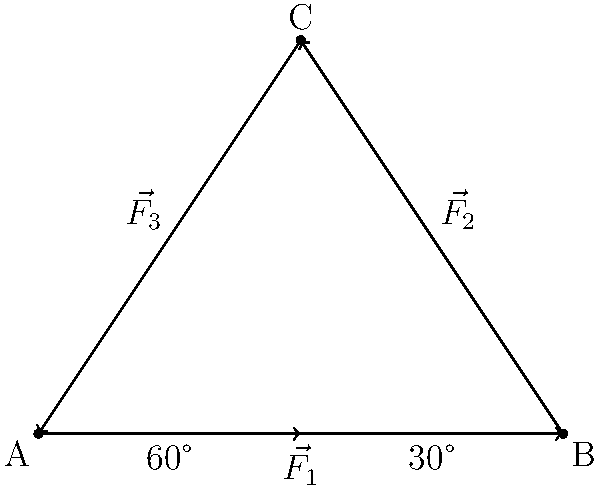The John G. Lawton's rigging system includes a triangular arrangement of forces as shown in the diagram. $\vec{F_1}$ has a magnitude of 1000 N and is horizontal. $\vec{F_2}$ makes an angle of 30° with the horizontal, and $\vec{F_3}$ makes an angle of 60° with the horizontal. If the system is in equilibrium, calculate the magnitude of $\vec{F_2}$. To solve this problem, we'll use the following steps:

1) For a system in equilibrium, the sum of forces in both x and y directions must be zero.

2) Let's define the positive x-direction as right and positive y-direction as up.

3) Break down the forces into their x and y components:
   $\vec{F_1}_x = 1000$ N, $\vec{F_1}_y = 0$ N
   $\vec{F_2}_x = F_2 \cos(30°)$, $\vec{F_2}_y = F_2 \sin(30°)$
   $\vec{F_3}_x = F_3 \cos(60°)$, $\vec{F_3}_y = -F_3 \sin(60°)$

4) Sum of forces in x-direction:
   $$\sum F_x = 0: 1000 + F_2 \cos(30°) + F_3 \cos(60°) = 0$$

5) Sum of forces in y-direction:
   $$\sum F_y = 0: F_2 \sin(30°) - F_3 \sin(60°) = 0$$

6) From equation in step 5:
   $$F_2 \sin(30°) = F_3 \sin(60°)$$
   $$F_2 (0.5) = F_3 (\frac{\sqrt{3}}{2})$$
   $$F_2 = F_3 \frac{\sqrt{3}}{\sqrt{3}} = F_3$$

7) Substitute this into the equation from step 4:
   $$1000 + F_2 \cos(30°) + F_2 \cos(60°) = 0$$
   $$1000 + F_2 (\frac{\sqrt{3}}{2} + 0.5) = 0$$
   $$1000 + F_2 (1.366) = 0$$

8) Solve for $F_2$:
   $$F_2 = \frac{-1000}{1.366} = 732.06 \text{ N}$$

Therefore, the magnitude of $\vec{F_2}$ is approximately 732.06 N.
Answer: 732.06 N 